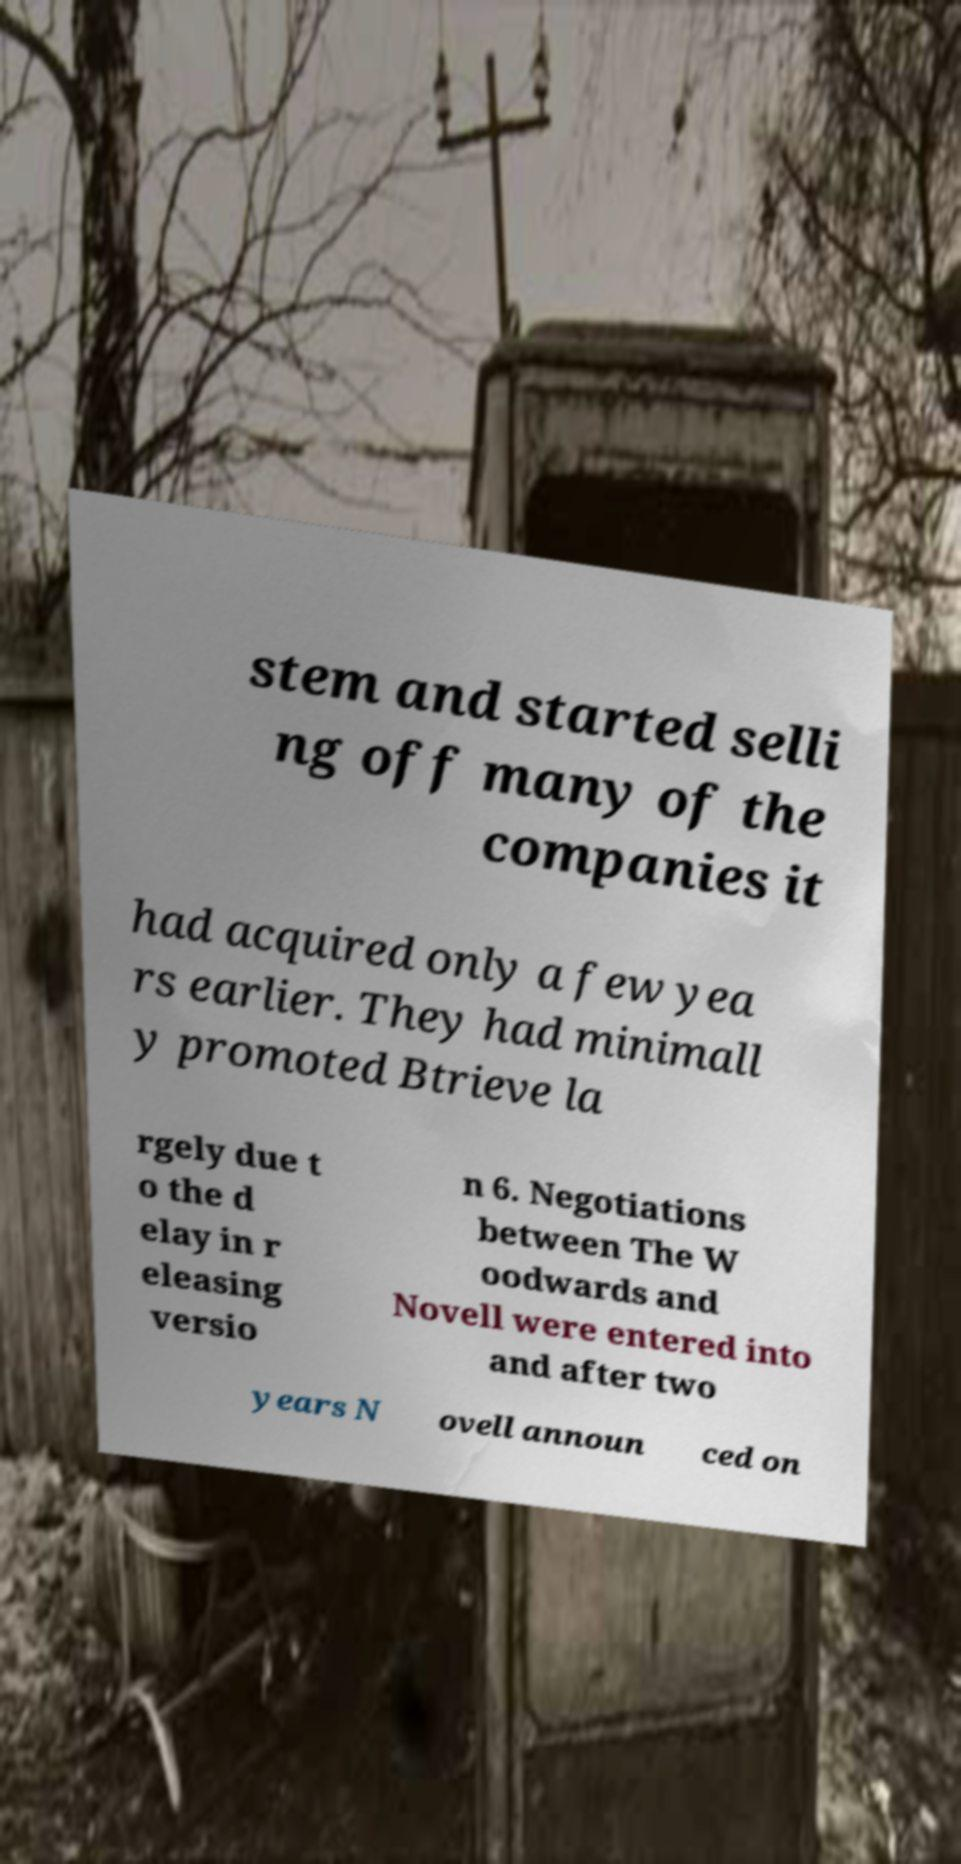Can you read and provide the text displayed in the image?This photo seems to have some interesting text. Can you extract and type it out for me? stem and started selli ng off many of the companies it had acquired only a few yea rs earlier. They had minimall y promoted Btrieve la rgely due t o the d elay in r eleasing versio n 6. Negotiations between The W oodwards and Novell were entered into and after two years N ovell announ ced on 